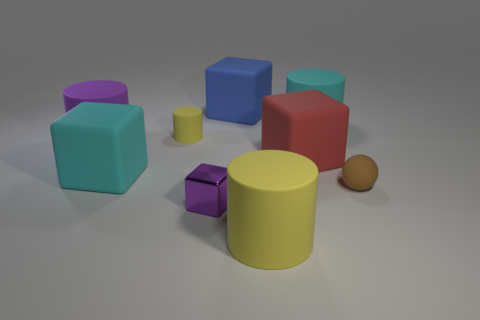What number of other objects are there of the same size as the brown rubber sphere?
Keep it short and to the point. 2. There is a object that is the same color as the small cube; what size is it?
Ensure brevity in your answer.  Large. There is a tiny matte thing that is left of the tiny matte sphere; is its shape the same as the big blue rubber object?
Keep it short and to the point. No. What number of other objects are the same shape as the small yellow rubber thing?
Keep it short and to the point. 3. There is a purple thing that is in front of the large purple thing; what shape is it?
Provide a short and direct response. Cube. Is there a big green object made of the same material as the large cyan cylinder?
Provide a short and direct response. No. There is a large rubber cylinder that is in front of the purple cylinder; is its color the same as the tiny cylinder?
Offer a terse response. Yes. What is the size of the cyan cylinder?
Give a very brief answer. Large. There is a big rubber cylinder that is to the left of the cube behind the red rubber cube; is there a blue matte block left of it?
Make the answer very short. No. There is a purple cylinder; how many big red objects are in front of it?
Your answer should be very brief. 1. 